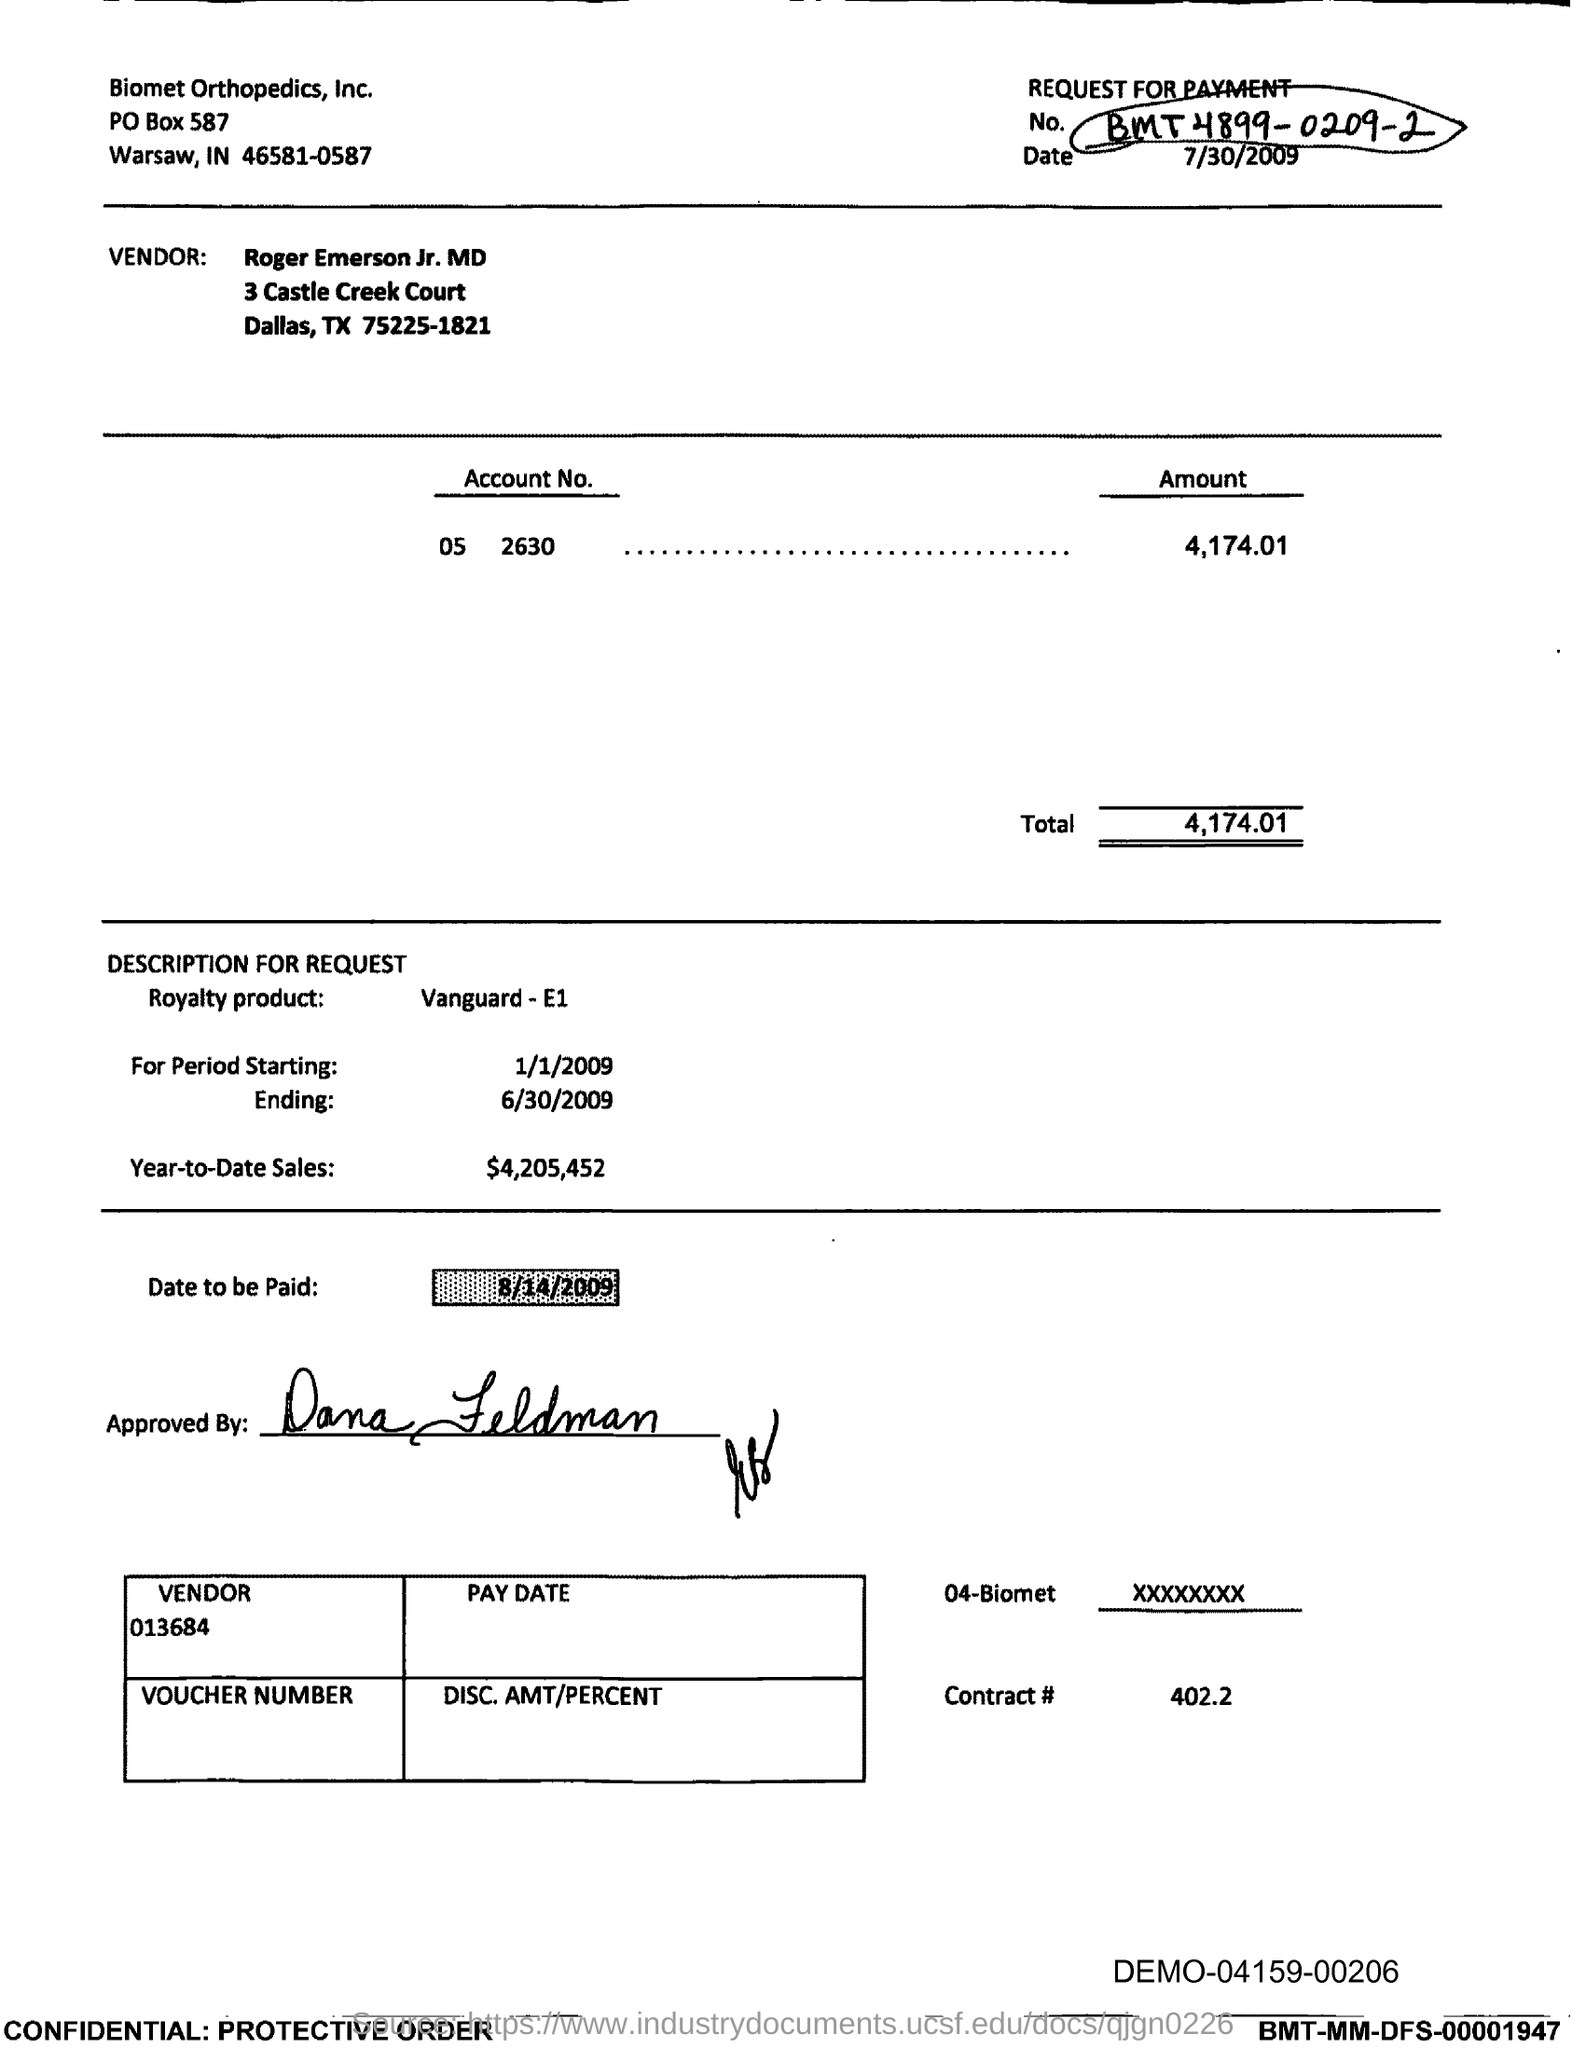What is the po box no. of biomet orthopedics, inc.?
Offer a very short reply. 587. In which state is biomet orthopedics, inc. located?
Your response must be concise. IN. What is the royalty product name ?
Provide a succinct answer. Vanguard-E1. What is the year-to-date sales?
Give a very brief answer. $4,205,452. What is the date to be paid ?
Offer a very short reply. 8/14/2009. What is the total ?
Keep it short and to the point. 4,174.01. What is vendor no.?
Your response must be concise. 013684. 